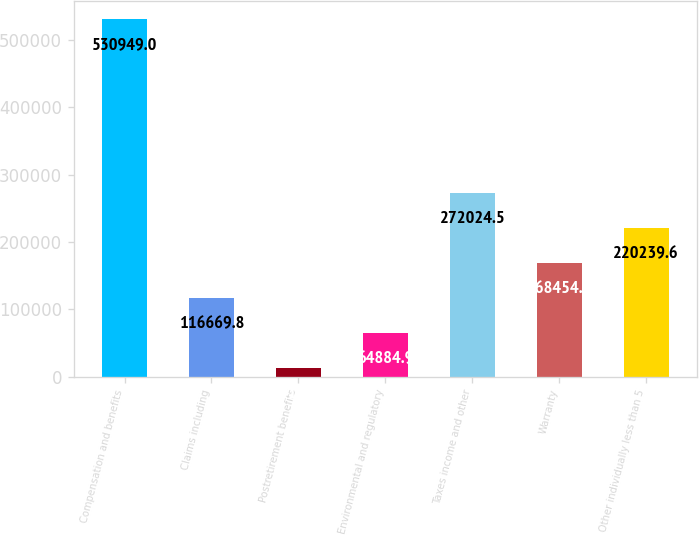Convert chart to OTSL. <chart><loc_0><loc_0><loc_500><loc_500><bar_chart><fcel>Compensation and benefits<fcel>Claims including<fcel>Postretirement benefits<fcel>Environmental and regulatory<fcel>Taxes income and other<fcel>Warranty<fcel>Other individually less than 5<nl><fcel>530949<fcel>116670<fcel>13100<fcel>64884.9<fcel>272024<fcel>168455<fcel>220240<nl></chart> 